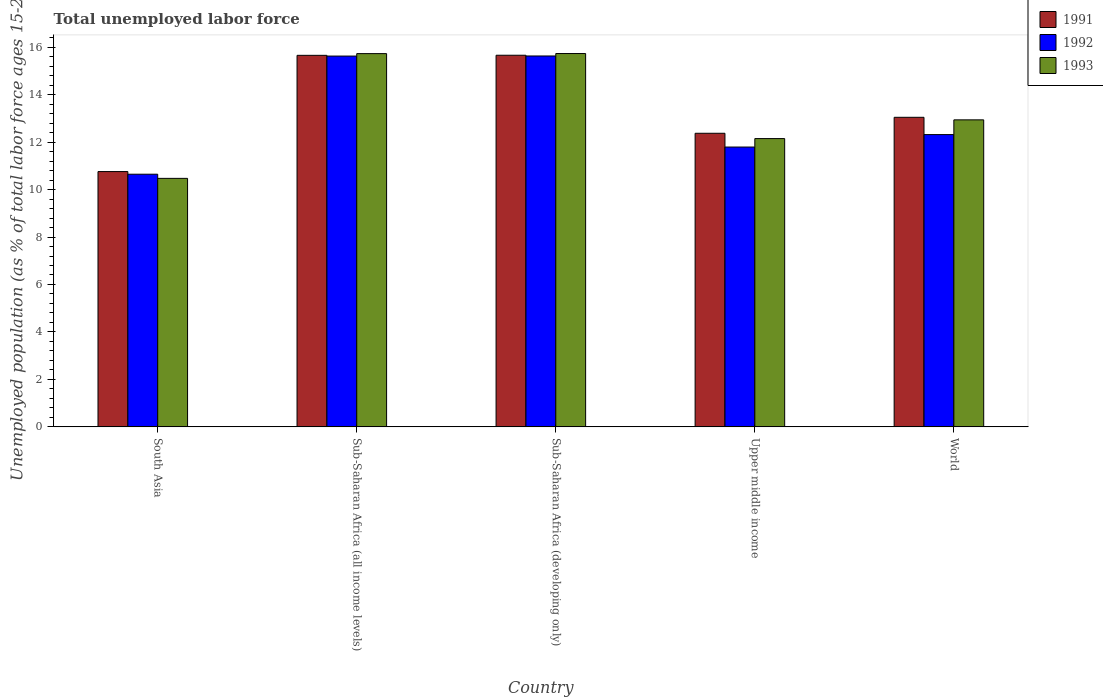How many groups of bars are there?
Give a very brief answer. 5. How many bars are there on the 3rd tick from the left?
Offer a very short reply. 3. How many bars are there on the 4th tick from the right?
Offer a very short reply. 3. What is the label of the 2nd group of bars from the left?
Provide a succinct answer. Sub-Saharan Africa (all income levels). What is the percentage of unemployed population in in 1991 in Upper middle income?
Offer a very short reply. 12.37. Across all countries, what is the maximum percentage of unemployed population in in 1992?
Keep it short and to the point. 15.63. Across all countries, what is the minimum percentage of unemployed population in in 1993?
Make the answer very short. 10.47. In which country was the percentage of unemployed population in in 1991 maximum?
Offer a very short reply. Sub-Saharan Africa (developing only). What is the total percentage of unemployed population in in 1991 in the graph?
Your response must be concise. 67.49. What is the difference between the percentage of unemployed population in in 1993 in South Asia and that in World?
Your answer should be very brief. -2.47. What is the difference between the percentage of unemployed population in in 1991 in South Asia and the percentage of unemployed population in in 1992 in Upper middle income?
Your answer should be compact. -1.03. What is the average percentage of unemployed population in in 1992 per country?
Provide a short and direct response. 13.2. What is the difference between the percentage of unemployed population in of/in 1991 and percentage of unemployed population in of/in 1992 in Upper middle income?
Your answer should be compact. 0.58. What is the ratio of the percentage of unemployed population in in 1992 in Sub-Saharan Africa (all income levels) to that in World?
Ensure brevity in your answer.  1.27. Is the percentage of unemployed population in in 1991 in Sub-Saharan Africa (all income levels) less than that in Sub-Saharan Africa (developing only)?
Offer a very short reply. Yes. What is the difference between the highest and the second highest percentage of unemployed population in in 1991?
Ensure brevity in your answer.  2.61. What is the difference between the highest and the lowest percentage of unemployed population in in 1992?
Your response must be concise. 4.98. In how many countries, is the percentage of unemployed population in in 1993 greater than the average percentage of unemployed population in in 1993 taken over all countries?
Your answer should be very brief. 2. Is the sum of the percentage of unemployed population in in 1993 in Sub-Saharan Africa (all income levels) and Upper middle income greater than the maximum percentage of unemployed population in in 1991 across all countries?
Your answer should be very brief. Yes. Is it the case that in every country, the sum of the percentage of unemployed population in in 1991 and percentage of unemployed population in in 1993 is greater than the percentage of unemployed population in in 1992?
Keep it short and to the point. Yes. How many bars are there?
Make the answer very short. 15. Are all the bars in the graph horizontal?
Your response must be concise. No. How many countries are there in the graph?
Your answer should be very brief. 5. What is the difference between two consecutive major ticks on the Y-axis?
Your answer should be very brief. 2. Are the values on the major ticks of Y-axis written in scientific E-notation?
Keep it short and to the point. No. Does the graph contain grids?
Provide a short and direct response. No. How many legend labels are there?
Offer a very short reply. 3. How are the legend labels stacked?
Ensure brevity in your answer.  Vertical. What is the title of the graph?
Keep it short and to the point. Total unemployed labor force. What is the label or title of the X-axis?
Offer a very short reply. Country. What is the label or title of the Y-axis?
Give a very brief answer. Unemployed population (as % of total labor force ages 15-24). What is the Unemployed population (as % of total labor force ages 15-24) in 1991 in South Asia?
Your response must be concise. 10.76. What is the Unemployed population (as % of total labor force ages 15-24) of 1992 in South Asia?
Keep it short and to the point. 10.65. What is the Unemployed population (as % of total labor force ages 15-24) in 1993 in South Asia?
Give a very brief answer. 10.47. What is the Unemployed population (as % of total labor force ages 15-24) of 1991 in Sub-Saharan Africa (all income levels)?
Offer a terse response. 15.66. What is the Unemployed population (as % of total labor force ages 15-24) of 1992 in Sub-Saharan Africa (all income levels)?
Offer a very short reply. 15.63. What is the Unemployed population (as % of total labor force ages 15-24) in 1993 in Sub-Saharan Africa (all income levels)?
Ensure brevity in your answer.  15.73. What is the Unemployed population (as % of total labor force ages 15-24) in 1991 in Sub-Saharan Africa (developing only)?
Make the answer very short. 15.66. What is the Unemployed population (as % of total labor force ages 15-24) of 1992 in Sub-Saharan Africa (developing only)?
Provide a short and direct response. 15.63. What is the Unemployed population (as % of total labor force ages 15-24) in 1993 in Sub-Saharan Africa (developing only)?
Offer a very short reply. 15.73. What is the Unemployed population (as % of total labor force ages 15-24) in 1991 in Upper middle income?
Make the answer very short. 12.37. What is the Unemployed population (as % of total labor force ages 15-24) of 1992 in Upper middle income?
Offer a terse response. 11.79. What is the Unemployed population (as % of total labor force ages 15-24) of 1993 in Upper middle income?
Make the answer very short. 12.15. What is the Unemployed population (as % of total labor force ages 15-24) of 1991 in World?
Ensure brevity in your answer.  13.04. What is the Unemployed population (as % of total labor force ages 15-24) in 1992 in World?
Give a very brief answer. 12.32. What is the Unemployed population (as % of total labor force ages 15-24) of 1993 in World?
Keep it short and to the point. 12.94. Across all countries, what is the maximum Unemployed population (as % of total labor force ages 15-24) of 1991?
Your answer should be very brief. 15.66. Across all countries, what is the maximum Unemployed population (as % of total labor force ages 15-24) of 1992?
Your answer should be very brief. 15.63. Across all countries, what is the maximum Unemployed population (as % of total labor force ages 15-24) in 1993?
Make the answer very short. 15.73. Across all countries, what is the minimum Unemployed population (as % of total labor force ages 15-24) of 1991?
Your answer should be compact. 10.76. Across all countries, what is the minimum Unemployed population (as % of total labor force ages 15-24) of 1992?
Your answer should be compact. 10.65. Across all countries, what is the minimum Unemployed population (as % of total labor force ages 15-24) in 1993?
Your answer should be very brief. 10.47. What is the total Unemployed population (as % of total labor force ages 15-24) of 1991 in the graph?
Ensure brevity in your answer.  67.49. What is the total Unemployed population (as % of total labor force ages 15-24) of 1992 in the graph?
Ensure brevity in your answer.  66.01. What is the total Unemployed population (as % of total labor force ages 15-24) in 1993 in the graph?
Your answer should be very brief. 67.02. What is the difference between the Unemployed population (as % of total labor force ages 15-24) of 1991 in South Asia and that in Sub-Saharan Africa (all income levels)?
Provide a succinct answer. -4.9. What is the difference between the Unemployed population (as % of total labor force ages 15-24) in 1992 in South Asia and that in Sub-Saharan Africa (all income levels)?
Offer a very short reply. -4.98. What is the difference between the Unemployed population (as % of total labor force ages 15-24) of 1993 in South Asia and that in Sub-Saharan Africa (all income levels)?
Offer a terse response. -5.26. What is the difference between the Unemployed population (as % of total labor force ages 15-24) of 1991 in South Asia and that in Sub-Saharan Africa (developing only)?
Make the answer very short. -4.9. What is the difference between the Unemployed population (as % of total labor force ages 15-24) in 1992 in South Asia and that in Sub-Saharan Africa (developing only)?
Make the answer very short. -4.98. What is the difference between the Unemployed population (as % of total labor force ages 15-24) of 1993 in South Asia and that in Sub-Saharan Africa (developing only)?
Your answer should be very brief. -5.26. What is the difference between the Unemployed population (as % of total labor force ages 15-24) of 1991 in South Asia and that in Upper middle income?
Your answer should be compact. -1.61. What is the difference between the Unemployed population (as % of total labor force ages 15-24) of 1992 in South Asia and that in Upper middle income?
Make the answer very short. -1.14. What is the difference between the Unemployed population (as % of total labor force ages 15-24) in 1993 in South Asia and that in Upper middle income?
Your answer should be compact. -1.68. What is the difference between the Unemployed population (as % of total labor force ages 15-24) in 1991 in South Asia and that in World?
Make the answer very short. -2.29. What is the difference between the Unemployed population (as % of total labor force ages 15-24) in 1992 in South Asia and that in World?
Your answer should be very brief. -1.67. What is the difference between the Unemployed population (as % of total labor force ages 15-24) in 1993 in South Asia and that in World?
Give a very brief answer. -2.47. What is the difference between the Unemployed population (as % of total labor force ages 15-24) in 1991 in Sub-Saharan Africa (all income levels) and that in Sub-Saharan Africa (developing only)?
Give a very brief answer. -0. What is the difference between the Unemployed population (as % of total labor force ages 15-24) in 1992 in Sub-Saharan Africa (all income levels) and that in Sub-Saharan Africa (developing only)?
Your response must be concise. -0. What is the difference between the Unemployed population (as % of total labor force ages 15-24) of 1993 in Sub-Saharan Africa (all income levels) and that in Sub-Saharan Africa (developing only)?
Ensure brevity in your answer.  -0. What is the difference between the Unemployed population (as % of total labor force ages 15-24) in 1991 in Sub-Saharan Africa (all income levels) and that in Upper middle income?
Your answer should be very brief. 3.28. What is the difference between the Unemployed population (as % of total labor force ages 15-24) in 1992 in Sub-Saharan Africa (all income levels) and that in Upper middle income?
Provide a succinct answer. 3.83. What is the difference between the Unemployed population (as % of total labor force ages 15-24) in 1993 in Sub-Saharan Africa (all income levels) and that in Upper middle income?
Offer a very short reply. 3.58. What is the difference between the Unemployed population (as % of total labor force ages 15-24) of 1991 in Sub-Saharan Africa (all income levels) and that in World?
Offer a terse response. 2.61. What is the difference between the Unemployed population (as % of total labor force ages 15-24) of 1992 in Sub-Saharan Africa (all income levels) and that in World?
Keep it short and to the point. 3.31. What is the difference between the Unemployed population (as % of total labor force ages 15-24) of 1993 in Sub-Saharan Africa (all income levels) and that in World?
Your answer should be very brief. 2.79. What is the difference between the Unemployed population (as % of total labor force ages 15-24) of 1991 in Sub-Saharan Africa (developing only) and that in Upper middle income?
Your response must be concise. 3.29. What is the difference between the Unemployed population (as % of total labor force ages 15-24) in 1992 in Sub-Saharan Africa (developing only) and that in Upper middle income?
Give a very brief answer. 3.84. What is the difference between the Unemployed population (as % of total labor force ages 15-24) of 1993 in Sub-Saharan Africa (developing only) and that in Upper middle income?
Make the answer very short. 3.58. What is the difference between the Unemployed population (as % of total labor force ages 15-24) of 1991 in Sub-Saharan Africa (developing only) and that in World?
Provide a short and direct response. 2.62. What is the difference between the Unemployed population (as % of total labor force ages 15-24) in 1992 in Sub-Saharan Africa (developing only) and that in World?
Provide a short and direct response. 3.31. What is the difference between the Unemployed population (as % of total labor force ages 15-24) of 1993 in Sub-Saharan Africa (developing only) and that in World?
Provide a succinct answer. 2.79. What is the difference between the Unemployed population (as % of total labor force ages 15-24) of 1991 in Upper middle income and that in World?
Keep it short and to the point. -0.67. What is the difference between the Unemployed population (as % of total labor force ages 15-24) of 1992 in Upper middle income and that in World?
Offer a very short reply. -0.52. What is the difference between the Unemployed population (as % of total labor force ages 15-24) in 1993 in Upper middle income and that in World?
Your answer should be compact. -0.79. What is the difference between the Unemployed population (as % of total labor force ages 15-24) of 1991 in South Asia and the Unemployed population (as % of total labor force ages 15-24) of 1992 in Sub-Saharan Africa (all income levels)?
Your response must be concise. -4.87. What is the difference between the Unemployed population (as % of total labor force ages 15-24) of 1991 in South Asia and the Unemployed population (as % of total labor force ages 15-24) of 1993 in Sub-Saharan Africa (all income levels)?
Your answer should be very brief. -4.97. What is the difference between the Unemployed population (as % of total labor force ages 15-24) in 1992 in South Asia and the Unemployed population (as % of total labor force ages 15-24) in 1993 in Sub-Saharan Africa (all income levels)?
Your response must be concise. -5.08. What is the difference between the Unemployed population (as % of total labor force ages 15-24) of 1991 in South Asia and the Unemployed population (as % of total labor force ages 15-24) of 1992 in Sub-Saharan Africa (developing only)?
Offer a very short reply. -4.87. What is the difference between the Unemployed population (as % of total labor force ages 15-24) in 1991 in South Asia and the Unemployed population (as % of total labor force ages 15-24) in 1993 in Sub-Saharan Africa (developing only)?
Keep it short and to the point. -4.97. What is the difference between the Unemployed population (as % of total labor force ages 15-24) of 1992 in South Asia and the Unemployed population (as % of total labor force ages 15-24) of 1993 in Sub-Saharan Africa (developing only)?
Your response must be concise. -5.08. What is the difference between the Unemployed population (as % of total labor force ages 15-24) in 1991 in South Asia and the Unemployed population (as % of total labor force ages 15-24) in 1992 in Upper middle income?
Keep it short and to the point. -1.03. What is the difference between the Unemployed population (as % of total labor force ages 15-24) in 1991 in South Asia and the Unemployed population (as % of total labor force ages 15-24) in 1993 in Upper middle income?
Your answer should be very brief. -1.39. What is the difference between the Unemployed population (as % of total labor force ages 15-24) in 1992 in South Asia and the Unemployed population (as % of total labor force ages 15-24) in 1993 in Upper middle income?
Provide a short and direct response. -1.5. What is the difference between the Unemployed population (as % of total labor force ages 15-24) in 1991 in South Asia and the Unemployed population (as % of total labor force ages 15-24) in 1992 in World?
Provide a succinct answer. -1.56. What is the difference between the Unemployed population (as % of total labor force ages 15-24) in 1991 in South Asia and the Unemployed population (as % of total labor force ages 15-24) in 1993 in World?
Ensure brevity in your answer.  -2.18. What is the difference between the Unemployed population (as % of total labor force ages 15-24) in 1992 in South Asia and the Unemployed population (as % of total labor force ages 15-24) in 1993 in World?
Offer a terse response. -2.29. What is the difference between the Unemployed population (as % of total labor force ages 15-24) of 1991 in Sub-Saharan Africa (all income levels) and the Unemployed population (as % of total labor force ages 15-24) of 1992 in Sub-Saharan Africa (developing only)?
Provide a succinct answer. 0.03. What is the difference between the Unemployed population (as % of total labor force ages 15-24) in 1991 in Sub-Saharan Africa (all income levels) and the Unemployed population (as % of total labor force ages 15-24) in 1993 in Sub-Saharan Africa (developing only)?
Provide a short and direct response. -0.08. What is the difference between the Unemployed population (as % of total labor force ages 15-24) in 1992 in Sub-Saharan Africa (all income levels) and the Unemployed population (as % of total labor force ages 15-24) in 1993 in Sub-Saharan Africa (developing only)?
Give a very brief answer. -0.11. What is the difference between the Unemployed population (as % of total labor force ages 15-24) of 1991 in Sub-Saharan Africa (all income levels) and the Unemployed population (as % of total labor force ages 15-24) of 1992 in Upper middle income?
Keep it short and to the point. 3.86. What is the difference between the Unemployed population (as % of total labor force ages 15-24) of 1991 in Sub-Saharan Africa (all income levels) and the Unemployed population (as % of total labor force ages 15-24) of 1993 in Upper middle income?
Give a very brief answer. 3.51. What is the difference between the Unemployed population (as % of total labor force ages 15-24) of 1992 in Sub-Saharan Africa (all income levels) and the Unemployed population (as % of total labor force ages 15-24) of 1993 in Upper middle income?
Offer a very short reply. 3.48. What is the difference between the Unemployed population (as % of total labor force ages 15-24) of 1991 in Sub-Saharan Africa (all income levels) and the Unemployed population (as % of total labor force ages 15-24) of 1992 in World?
Keep it short and to the point. 3.34. What is the difference between the Unemployed population (as % of total labor force ages 15-24) of 1991 in Sub-Saharan Africa (all income levels) and the Unemployed population (as % of total labor force ages 15-24) of 1993 in World?
Your answer should be very brief. 2.72. What is the difference between the Unemployed population (as % of total labor force ages 15-24) of 1992 in Sub-Saharan Africa (all income levels) and the Unemployed population (as % of total labor force ages 15-24) of 1993 in World?
Provide a succinct answer. 2.69. What is the difference between the Unemployed population (as % of total labor force ages 15-24) of 1991 in Sub-Saharan Africa (developing only) and the Unemployed population (as % of total labor force ages 15-24) of 1992 in Upper middle income?
Keep it short and to the point. 3.87. What is the difference between the Unemployed population (as % of total labor force ages 15-24) of 1991 in Sub-Saharan Africa (developing only) and the Unemployed population (as % of total labor force ages 15-24) of 1993 in Upper middle income?
Your answer should be compact. 3.51. What is the difference between the Unemployed population (as % of total labor force ages 15-24) in 1992 in Sub-Saharan Africa (developing only) and the Unemployed population (as % of total labor force ages 15-24) in 1993 in Upper middle income?
Make the answer very short. 3.48. What is the difference between the Unemployed population (as % of total labor force ages 15-24) of 1991 in Sub-Saharan Africa (developing only) and the Unemployed population (as % of total labor force ages 15-24) of 1992 in World?
Provide a succinct answer. 3.34. What is the difference between the Unemployed population (as % of total labor force ages 15-24) in 1991 in Sub-Saharan Africa (developing only) and the Unemployed population (as % of total labor force ages 15-24) in 1993 in World?
Keep it short and to the point. 2.72. What is the difference between the Unemployed population (as % of total labor force ages 15-24) in 1992 in Sub-Saharan Africa (developing only) and the Unemployed population (as % of total labor force ages 15-24) in 1993 in World?
Your response must be concise. 2.69. What is the difference between the Unemployed population (as % of total labor force ages 15-24) of 1991 in Upper middle income and the Unemployed population (as % of total labor force ages 15-24) of 1992 in World?
Make the answer very short. 0.06. What is the difference between the Unemployed population (as % of total labor force ages 15-24) of 1991 in Upper middle income and the Unemployed population (as % of total labor force ages 15-24) of 1993 in World?
Provide a succinct answer. -0.57. What is the difference between the Unemployed population (as % of total labor force ages 15-24) of 1992 in Upper middle income and the Unemployed population (as % of total labor force ages 15-24) of 1993 in World?
Ensure brevity in your answer.  -1.15. What is the average Unemployed population (as % of total labor force ages 15-24) of 1991 per country?
Your response must be concise. 13.5. What is the average Unemployed population (as % of total labor force ages 15-24) of 1992 per country?
Give a very brief answer. 13.2. What is the average Unemployed population (as % of total labor force ages 15-24) in 1993 per country?
Your answer should be very brief. 13.4. What is the difference between the Unemployed population (as % of total labor force ages 15-24) of 1991 and Unemployed population (as % of total labor force ages 15-24) of 1992 in South Asia?
Offer a terse response. 0.11. What is the difference between the Unemployed population (as % of total labor force ages 15-24) in 1991 and Unemployed population (as % of total labor force ages 15-24) in 1993 in South Asia?
Ensure brevity in your answer.  0.29. What is the difference between the Unemployed population (as % of total labor force ages 15-24) of 1992 and Unemployed population (as % of total labor force ages 15-24) of 1993 in South Asia?
Your answer should be compact. 0.18. What is the difference between the Unemployed population (as % of total labor force ages 15-24) of 1991 and Unemployed population (as % of total labor force ages 15-24) of 1992 in Sub-Saharan Africa (all income levels)?
Give a very brief answer. 0.03. What is the difference between the Unemployed population (as % of total labor force ages 15-24) of 1991 and Unemployed population (as % of total labor force ages 15-24) of 1993 in Sub-Saharan Africa (all income levels)?
Offer a very short reply. -0.07. What is the difference between the Unemployed population (as % of total labor force ages 15-24) of 1992 and Unemployed population (as % of total labor force ages 15-24) of 1993 in Sub-Saharan Africa (all income levels)?
Offer a very short reply. -0.1. What is the difference between the Unemployed population (as % of total labor force ages 15-24) in 1991 and Unemployed population (as % of total labor force ages 15-24) in 1992 in Sub-Saharan Africa (developing only)?
Provide a succinct answer. 0.03. What is the difference between the Unemployed population (as % of total labor force ages 15-24) of 1991 and Unemployed population (as % of total labor force ages 15-24) of 1993 in Sub-Saharan Africa (developing only)?
Make the answer very short. -0.07. What is the difference between the Unemployed population (as % of total labor force ages 15-24) in 1992 and Unemployed population (as % of total labor force ages 15-24) in 1993 in Sub-Saharan Africa (developing only)?
Your response must be concise. -0.1. What is the difference between the Unemployed population (as % of total labor force ages 15-24) in 1991 and Unemployed population (as % of total labor force ages 15-24) in 1992 in Upper middle income?
Keep it short and to the point. 0.58. What is the difference between the Unemployed population (as % of total labor force ages 15-24) of 1991 and Unemployed population (as % of total labor force ages 15-24) of 1993 in Upper middle income?
Provide a succinct answer. 0.22. What is the difference between the Unemployed population (as % of total labor force ages 15-24) in 1992 and Unemployed population (as % of total labor force ages 15-24) in 1993 in Upper middle income?
Your response must be concise. -0.36. What is the difference between the Unemployed population (as % of total labor force ages 15-24) in 1991 and Unemployed population (as % of total labor force ages 15-24) in 1992 in World?
Ensure brevity in your answer.  0.73. What is the difference between the Unemployed population (as % of total labor force ages 15-24) of 1991 and Unemployed population (as % of total labor force ages 15-24) of 1993 in World?
Give a very brief answer. 0.11. What is the difference between the Unemployed population (as % of total labor force ages 15-24) of 1992 and Unemployed population (as % of total labor force ages 15-24) of 1993 in World?
Provide a short and direct response. -0.62. What is the ratio of the Unemployed population (as % of total labor force ages 15-24) in 1991 in South Asia to that in Sub-Saharan Africa (all income levels)?
Ensure brevity in your answer.  0.69. What is the ratio of the Unemployed population (as % of total labor force ages 15-24) in 1992 in South Asia to that in Sub-Saharan Africa (all income levels)?
Keep it short and to the point. 0.68. What is the ratio of the Unemployed population (as % of total labor force ages 15-24) of 1993 in South Asia to that in Sub-Saharan Africa (all income levels)?
Provide a succinct answer. 0.67. What is the ratio of the Unemployed population (as % of total labor force ages 15-24) in 1991 in South Asia to that in Sub-Saharan Africa (developing only)?
Make the answer very short. 0.69. What is the ratio of the Unemployed population (as % of total labor force ages 15-24) of 1992 in South Asia to that in Sub-Saharan Africa (developing only)?
Offer a very short reply. 0.68. What is the ratio of the Unemployed population (as % of total labor force ages 15-24) of 1993 in South Asia to that in Sub-Saharan Africa (developing only)?
Your answer should be very brief. 0.67. What is the ratio of the Unemployed population (as % of total labor force ages 15-24) in 1991 in South Asia to that in Upper middle income?
Keep it short and to the point. 0.87. What is the ratio of the Unemployed population (as % of total labor force ages 15-24) of 1992 in South Asia to that in Upper middle income?
Make the answer very short. 0.9. What is the ratio of the Unemployed population (as % of total labor force ages 15-24) of 1993 in South Asia to that in Upper middle income?
Offer a very short reply. 0.86. What is the ratio of the Unemployed population (as % of total labor force ages 15-24) in 1991 in South Asia to that in World?
Your answer should be compact. 0.82. What is the ratio of the Unemployed population (as % of total labor force ages 15-24) of 1992 in South Asia to that in World?
Your answer should be very brief. 0.86. What is the ratio of the Unemployed population (as % of total labor force ages 15-24) of 1993 in South Asia to that in World?
Give a very brief answer. 0.81. What is the ratio of the Unemployed population (as % of total labor force ages 15-24) in 1992 in Sub-Saharan Africa (all income levels) to that in Sub-Saharan Africa (developing only)?
Offer a terse response. 1. What is the ratio of the Unemployed population (as % of total labor force ages 15-24) in 1991 in Sub-Saharan Africa (all income levels) to that in Upper middle income?
Keep it short and to the point. 1.27. What is the ratio of the Unemployed population (as % of total labor force ages 15-24) of 1992 in Sub-Saharan Africa (all income levels) to that in Upper middle income?
Make the answer very short. 1.33. What is the ratio of the Unemployed population (as % of total labor force ages 15-24) of 1993 in Sub-Saharan Africa (all income levels) to that in Upper middle income?
Your answer should be very brief. 1.29. What is the ratio of the Unemployed population (as % of total labor force ages 15-24) in 1991 in Sub-Saharan Africa (all income levels) to that in World?
Offer a terse response. 1.2. What is the ratio of the Unemployed population (as % of total labor force ages 15-24) in 1992 in Sub-Saharan Africa (all income levels) to that in World?
Offer a very short reply. 1.27. What is the ratio of the Unemployed population (as % of total labor force ages 15-24) in 1993 in Sub-Saharan Africa (all income levels) to that in World?
Make the answer very short. 1.22. What is the ratio of the Unemployed population (as % of total labor force ages 15-24) in 1991 in Sub-Saharan Africa (developing only) to that in Upper middle income?
Keep it short and to the point. 1.27. What is the ratio of the Unemployed population (as % of total labor force ages 15-24) in 1992 in Sub-Saharan Africa (developing only) to that in Upper middle income?
Provide a succinct answer. 1.33. What is the ratio of the Unemployed population (as % of total labor force ages 15-24) of 1993 in Sub-Saharan Africa (developing only) to that in Upper middle income?
Offer a terse response. 1.29. What is the ratio of the Unemployed population (as % of total labor force ages 15-24) of 1991 in Sub-Saharan Africa (developing only) to that in World?
Offer a terse response. 1.2. What is the ratio of the Unemployed population (as % of total labor force ages 15-24) in 1992 in Sub-Saharan Africa (developing only) to that in World?
Make the answer very short. 1.27. What is the ratio of the Unemployed population (as % of total labor force ages 15-24) of 1993 in Sub-Saharan Africa (developing only) to that in World?
Give a very brief answer. 1.22. What is the ratio of the Unemployed population (as % of total labor force ages 15-24) of 1991 in Upper middle income to that in World?
Give a very brief answer. 0.95. What is the ratio of the Unemployed population (as % of total labor force ages 15-24) in 1992 in Upper middle income to that in World?
Your answer should be very brief. 0.96. What is the ratio of the Unemployed population (as % of total labor force ages 15-24) of 1993 in Upper middle income to that in World?
Your answer should be very brief. 0.94. What is the difference between the highest and the second highest Unemployed population (as % of total labor force ages 15-24) of 1991?
Your answer should be very brief. 0. What is the difference between the highest and the second highest Unemployed population (as % of total labor force ages 15-24) of 1992?
Provide a short and direct response. 0. What is the difference between the highest and the second highest Unemployed population (as % of total labor force ages 15-24) of 1993?
Provide a succinct answer. 0. What is the difference between the highest and the lowest Unemployed population (as % of total labor force ages 15-24) in 1991?
Provide a short and direct response. 4.9. What is the difference between the highest and the lowest Unemployed population (as % of total labor force ages 15-24) in 1992?
Provide a short and direct response. 4.98. What is the difference between the highest and the lowest Unemployed population (as % of total labor force ages 15-24) of 1993?
Provide a short and direct response. 5.26. 